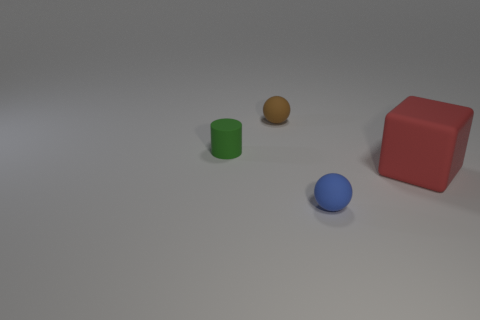What size is the rubber object that is behind the big cube and on the right side of the rubber cylinder?
Keep it short and to the point. Small. Do the green object and the small matte object in front of the tiny green cylinder have the same shape?
Your answer should be very brief. No. What size is the other object that is the same shape as the blue matte thing?
Your response must be concise. Small. Does the cylinder have the same color as the tiny rubber ball left of the blue rubber sphere?
Keep it short and to the point. No. What number of other things are the same size as the brown object?
Your answer should be compact. 2. There is a small rubber object to the right of the small matte ball that is behind the tiny rubber object in front of the large matte thing; what shape is it?
Give a very brief answer. Sphere. Do the blue rubber ball and the sphere that is on the left side of the tiny blue ball have the same size?
Provide a short and direct response. Yes. There is a object that is in front of the brown rubber thing and on the left side of the blue ball; what color is it?
Make the answer very short. Green. How many other things are there of the same shape as the tiny blue thing?
Provide a succinct answer. 1. There is a ball behind the blue rubber ball; is its color the same as the matte object that is right of the blue object?
Your answer should be very brief. No. 